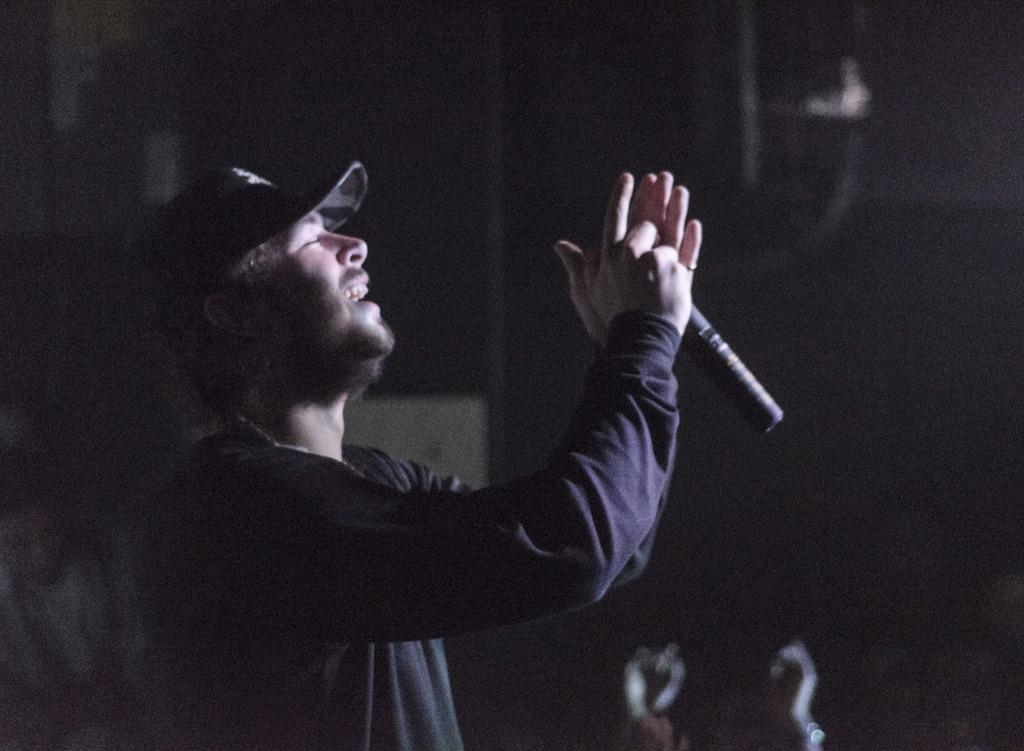Where was the image taken? The image was taken indoors. Can you describe the background of the image? The background of the image is blurred and dark. Who is present in the image? There is a man on the left side of the image. What is the man holding in his hands? The man is holding a mic in his hands. What type of digestion process is happening in the image? There is no digestion process present in the image. What view can be seen through the window in the image? There is no window visible in the image. 